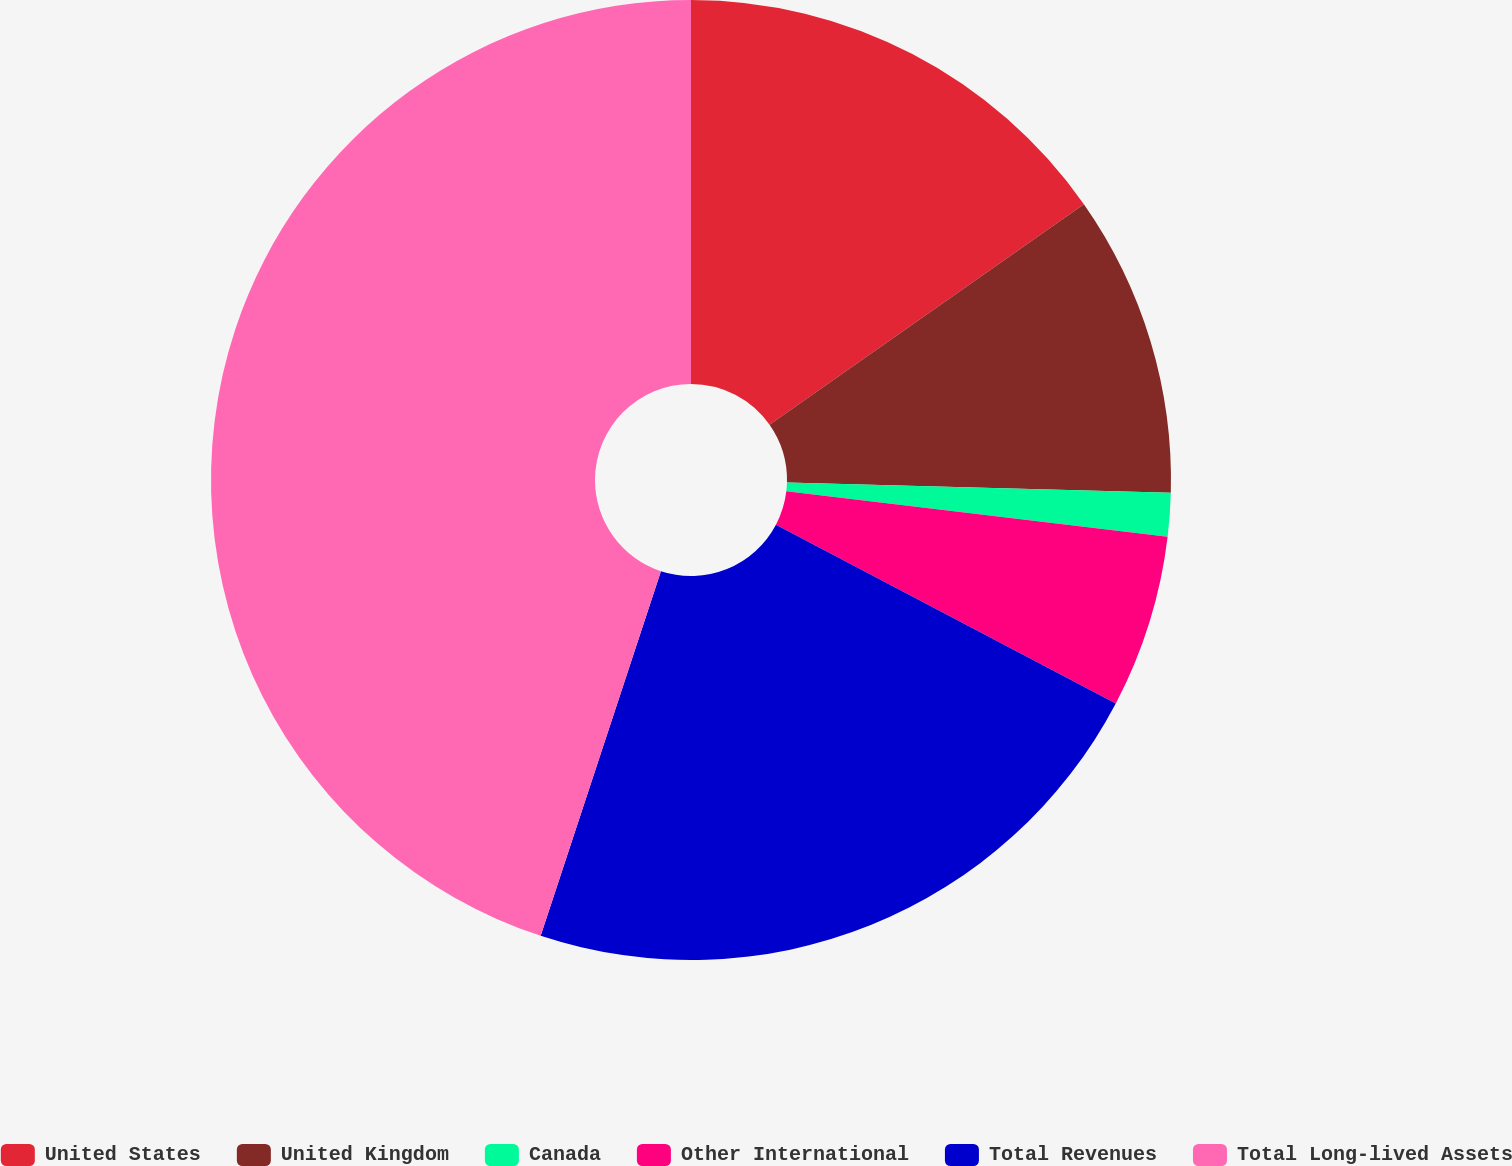<chart> <loc_0><loc_0><loc_500><loc_500><pie_chart><fcel>United States<fcel>United Kingdom<fcel>Canada<fcel>Other International<fcel>Total Revenues<fcel>Total Long-lived Assets<nl><fcel>15.26%<fcel>10.16%<fcel>1.47%<fcel>5.82%<fcel>22.36%<fcel>44.93%<nl></chart> 